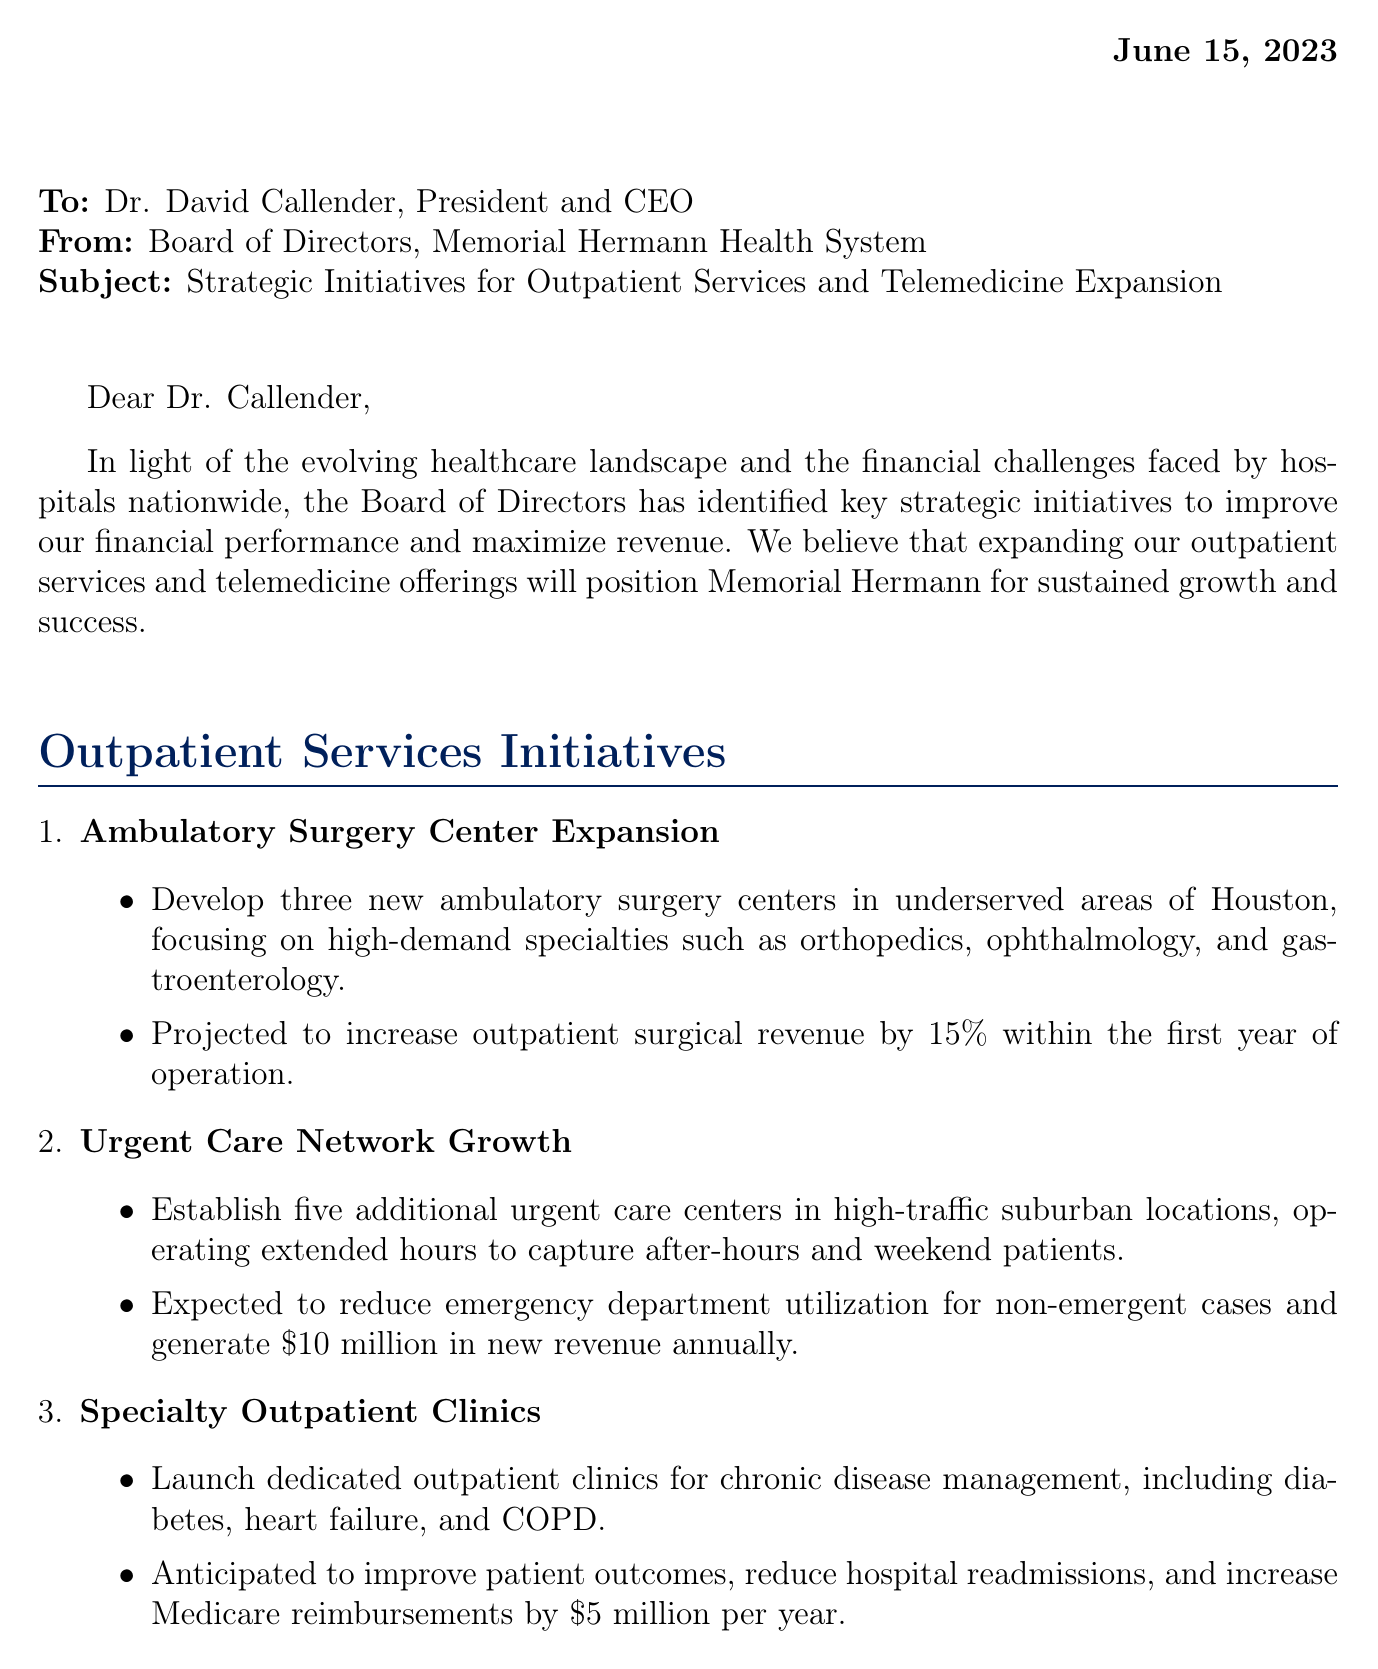what is the date of the letter? The date of the letter is stated in the document header.
Answer: June 15, 2023 who is the chair of the board of directors? The letter mentions the name and title of the person signing off on the letter.
Answer: Donald J. Wolterman how many new ambulatory surgery centers are planned? The document specifies the number of new centers to be developed in the outpatient services initiatives.
Answer: three what is the expected revenue from urgent care network growth? The letter outlines the projected revenue generation from establishing additional urgent care centers.
Answer: $10 million how much is the initial investment required for the initiatives? The letter mentions the total initial investment needed for the proposed initiatives.
Answer: $50 million what is the main objective of the outpatient services initiatives? The document outlines the primary aim of these initiatives related to financial performance.
Answer: increase outpatient surgical revenue what increase in patient retention is projected from the Virtual Primary Care Program? The letter indicates the expected percentage increase in patient retention from this telemedicine initiative.
Answer: 10% what is the projected reduction in hospital readmissions from remote patient monitoring? The document includes the anticipated percentage reduction in hospital readmissions due to the implementation of this technology.
Answer: 20% 